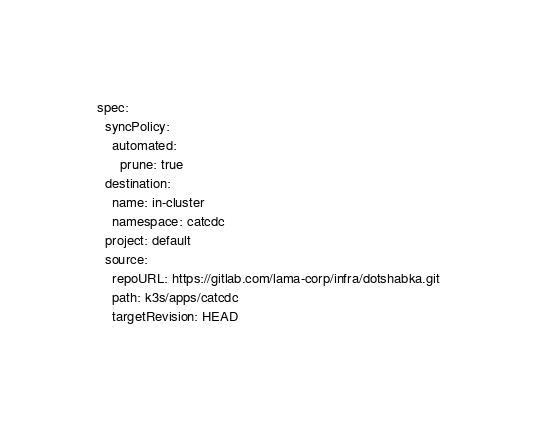Convert code to text. <code><loc_0><loc_0><loc_500><loc_500><_YAML_>spec:
  syncPolicy:
    automated:
      prune: true
  destination:
    name: in-cluster
    namespace: catcdc
  project: default
  source:
    repoURL: https://gitlab.com/lama-corp/infra/dotshabka.git
    path: k3s/apps/catcdc
    targetRevision: HEAD
</code> 